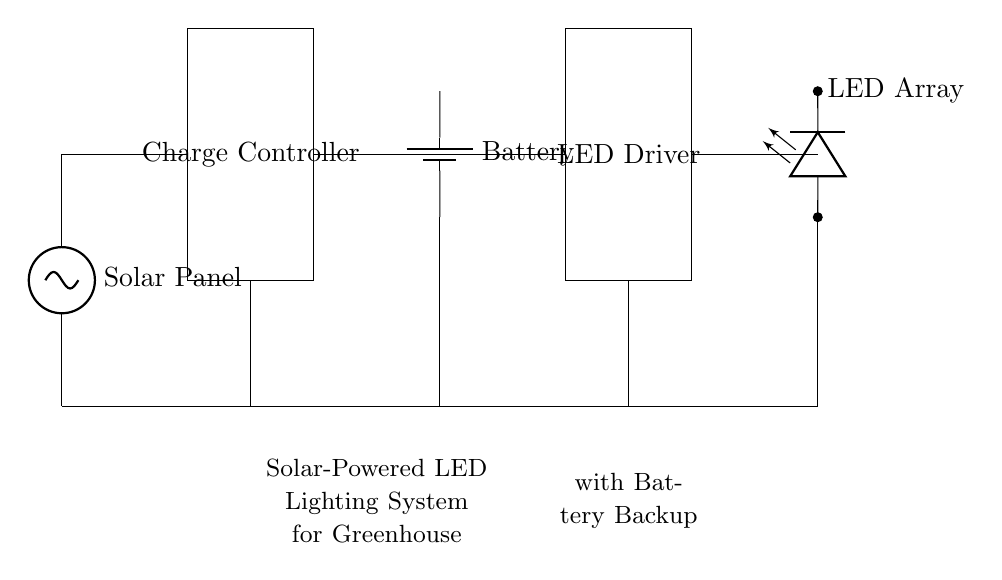What component generates energy for the system? The solar panel converts sunlight into electrical energy, which is essential for the operation of the system.
Answer: Solar Panel What stores energy in this circuit? The battery is used to store energy generated by the solar panel, allowing for use when sunlight is unavailable.
Answer: Battery Which component regulates the voltage from the solar panel? The charge controller is responsible for regulating the voltage and current coming from the solar panel, ensuring it is safe for the battery and other components.
Answer: Charge Controller What is the purpose of the LED driver? The LED driver controls the power delivered to the LED array, ensuring optimal performance and preventing damage from excessive current.
Answer: LED Driver How many main components are there in this circuit? There are five main components in this circuit: the solar panel, charge controller, battery, LED driver, and LED array.
Answer: Five What would happen if the battery was removed from the circuit? Without the battery, there would be no energy storage, meaning the LED array would only work when the solar panel is generating electricity, and there would be no illumination at night or during cloudy conditions.
Answer: No energy storage What voltage does the LED array operate at? The LED array typically operates at a low voltage, often around 12 volts, but the exact voltage may depend on the specifics of the design indicated in the circuit diagram.
Answer: Approximately 12 volts 